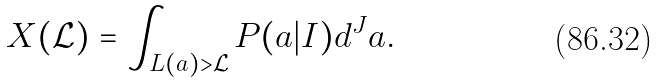<formula> <loc_0><loc_0><loc_500><loc_500>X ( \mathcal { L } ) = \int _ { L ( a ) > \mathcal { L } } P ( a | I ) d ^ { J } a .</formula> 